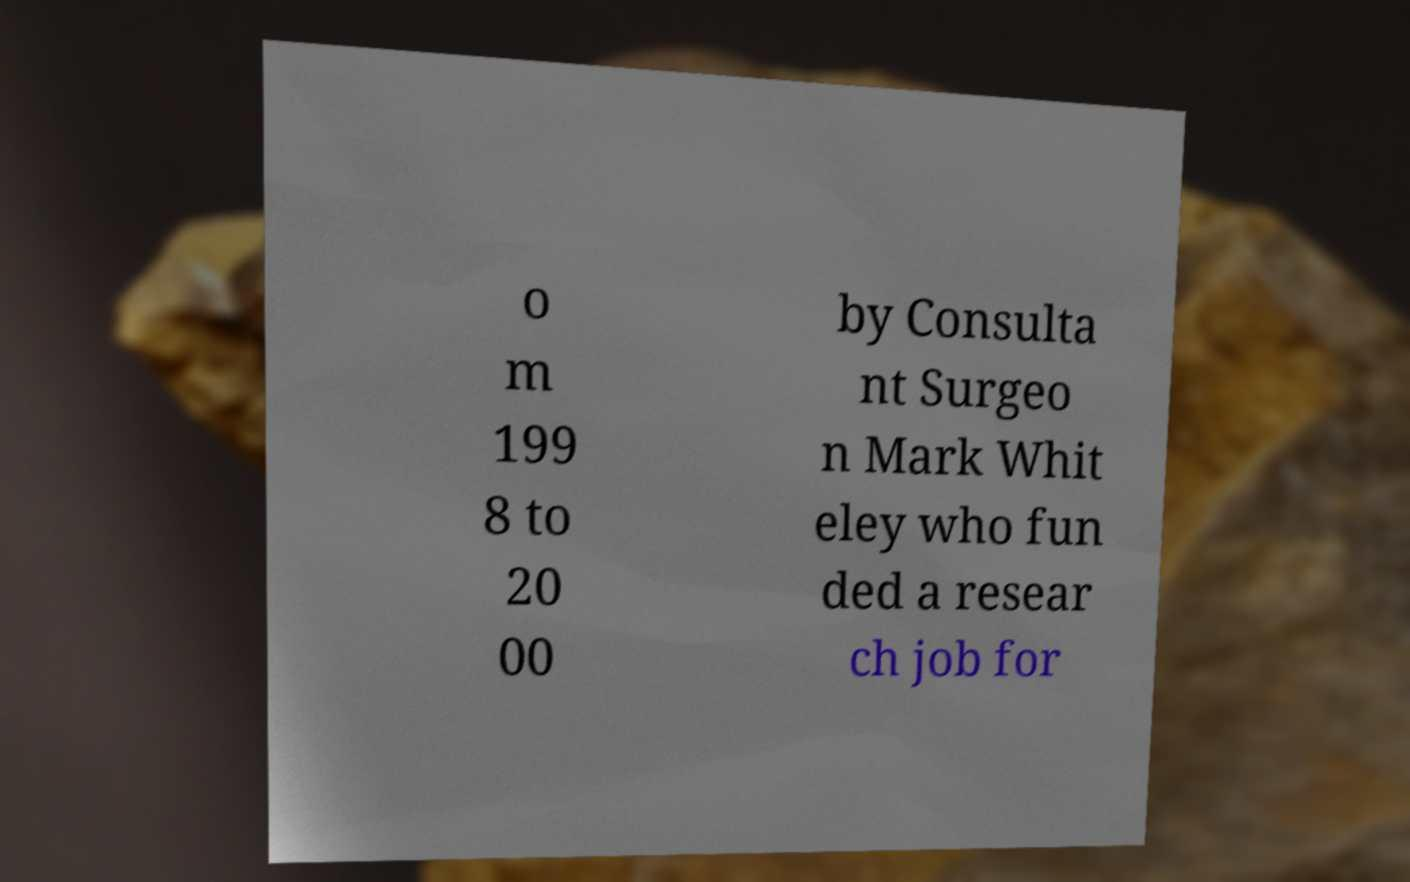Please read and relay the text visible in this image. What does it say? o m 199 8 to 20 00 by Consulta nt Surgeo n Mark Whit eley who fun ded a resear ch job for 